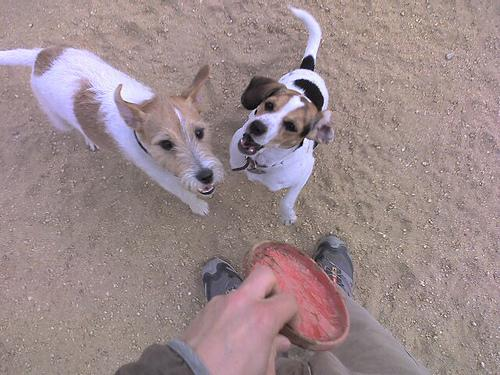Question: what color is the disc?
Choices:
A. Silver.
B. Red.
C. White.
D. Black.
Answer with the letter. Answer: B Question: what color are the shoes?
Choices:
A. Gray.
B. White.
C. Black.
D. Blue.
Answer with the letter. Answer: A Question: how many dogs are there?
Choices:
A. Two.
B. Three.
C. Four.
D. Five.
Answer with the letter. Answer: A 